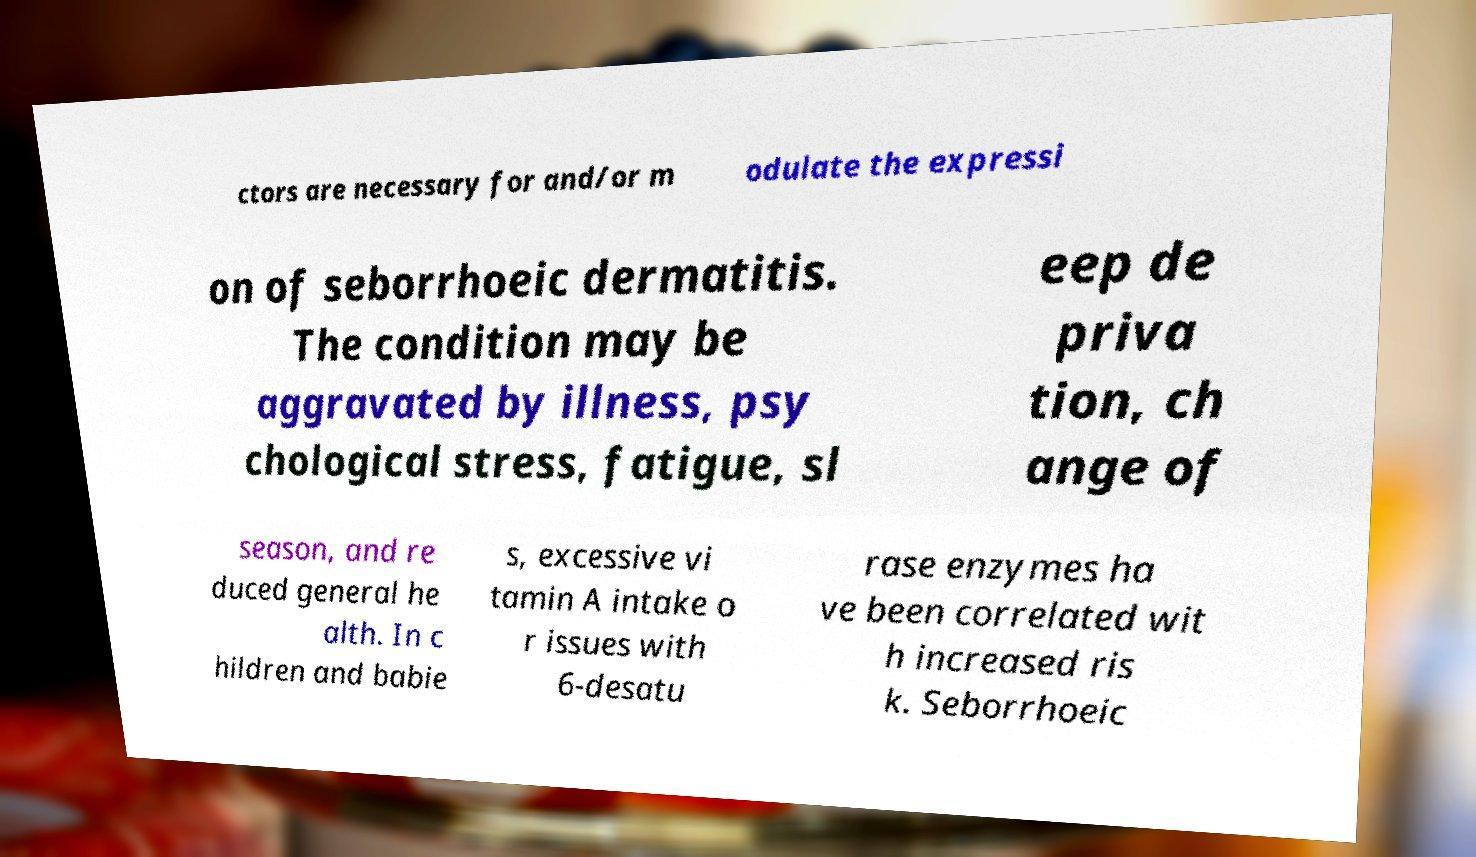Could you extract and type out the text from this image? ctors are necessary for and/or m odulate the expressi on of seborrhoeic dermatitis. The condition may be aggravated by illness, psy chological stress, fatigue, sl eep de priva tion, ch ange of season, and re duced general he alth. In c hildren and babie s, excessive vi tamin A intake o r issues with 6-desatu rase enzymes ha ve been correlated wit h increased ris k. Seborrhoeic 